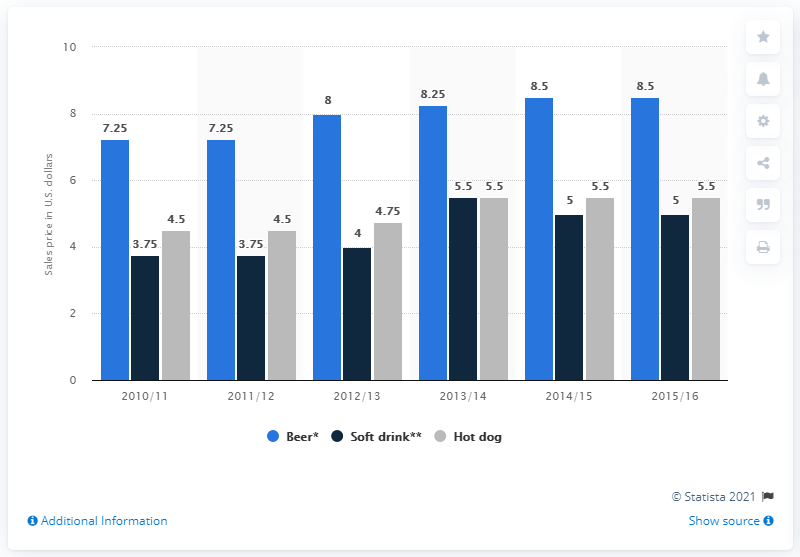List a handful of essential elements in this visual. In the 2013-14 season, the cost of a 16 ounce beer was 8.25. 